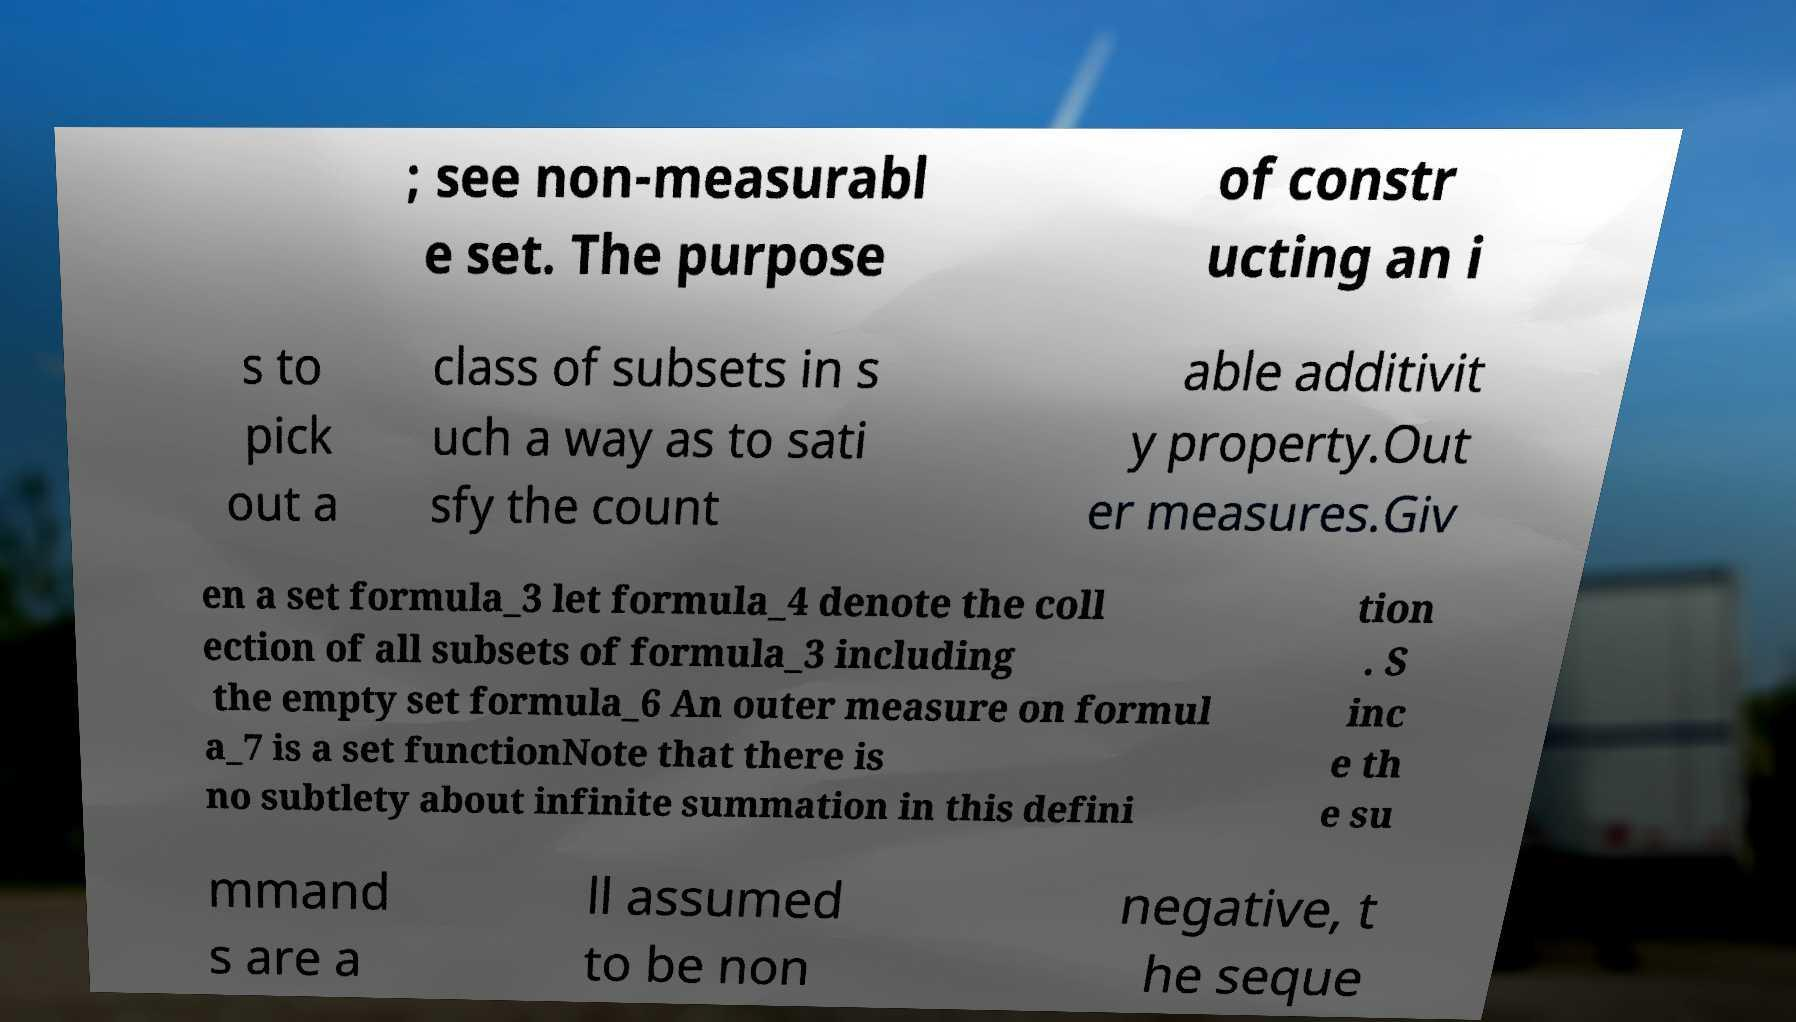Could you assist in decoding the text presented in this image and type it out clearly? ; see non-measurabl e set. The purpose of constr ucting an i s to pick out a class of subsets in s uch a way as to sati sfy the count able additivit y property.Out er measures.Giv en a set formula_3 let formula_4 denote the coll ection of all subsets of formula_3 including the empty set formula_6 An outer measure on formul a_7 is a set functionNote that there is no subtlety about infinite summation in this defini tion . S inc e th e su mmand s are a ll assumed to be non negative, t he seque 